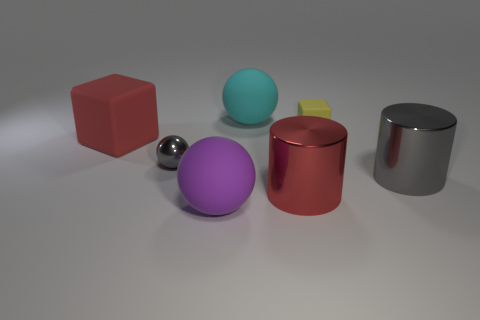Subtract 2 cubes. How many cubes are left? 0 Add 1 large cylinders. How many objects exist? 8 Subtract all big matte spheres. How many spheres are left? 1 Subtract all yellow cubes. How many cubes are left? 1 Subtract all cylinders. How many objects are left? 5 Subtract all cyan balls. Subtract all cyan cubes. How many balls are left? 2 Subtract all brown spheres. How many red blocks are left? 1 Subtract all large red matte objects. Subtract all large blocks. How many objects are left? 5 Add 6 gray spheres. How many gray spheres are left? 7 Add 3 cyan things. How many cyan things exist? 4 